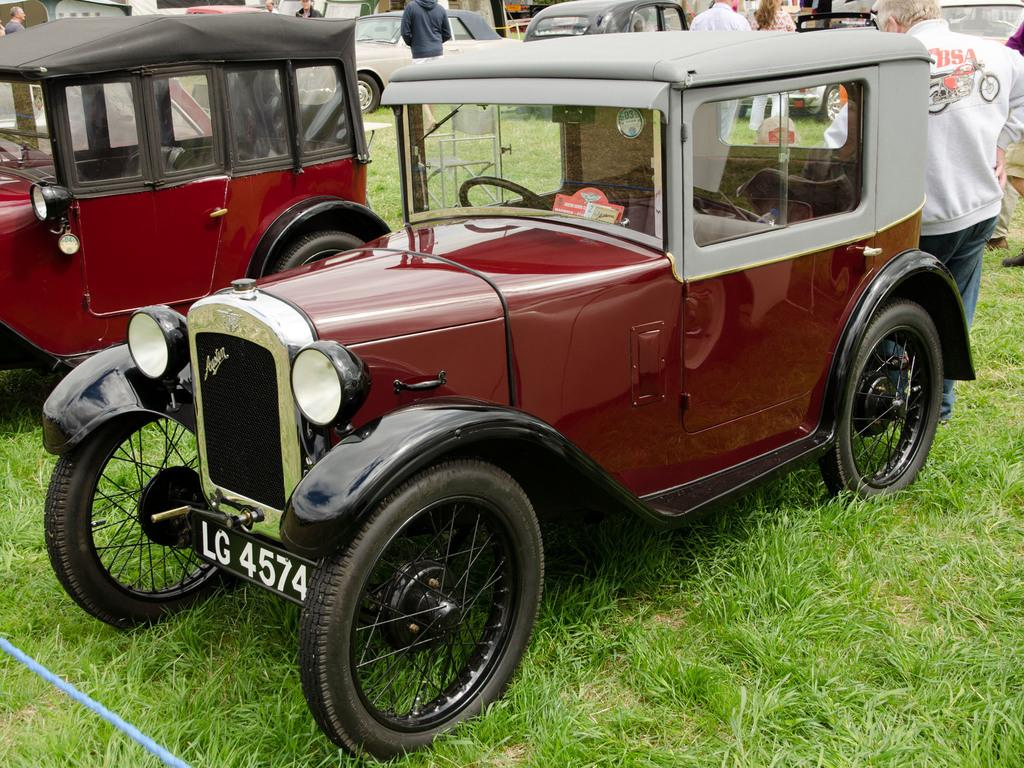What types of vehicles can be seen in the image? There are different vehicles in the image. Where are the vehicles located? The vehicles are on a grass surface. Are there any people present in the image? Yes, there are people between the vehicles. What type of fiction is being read by the wren in the image? There is no wren or any form of literature present in the image. 